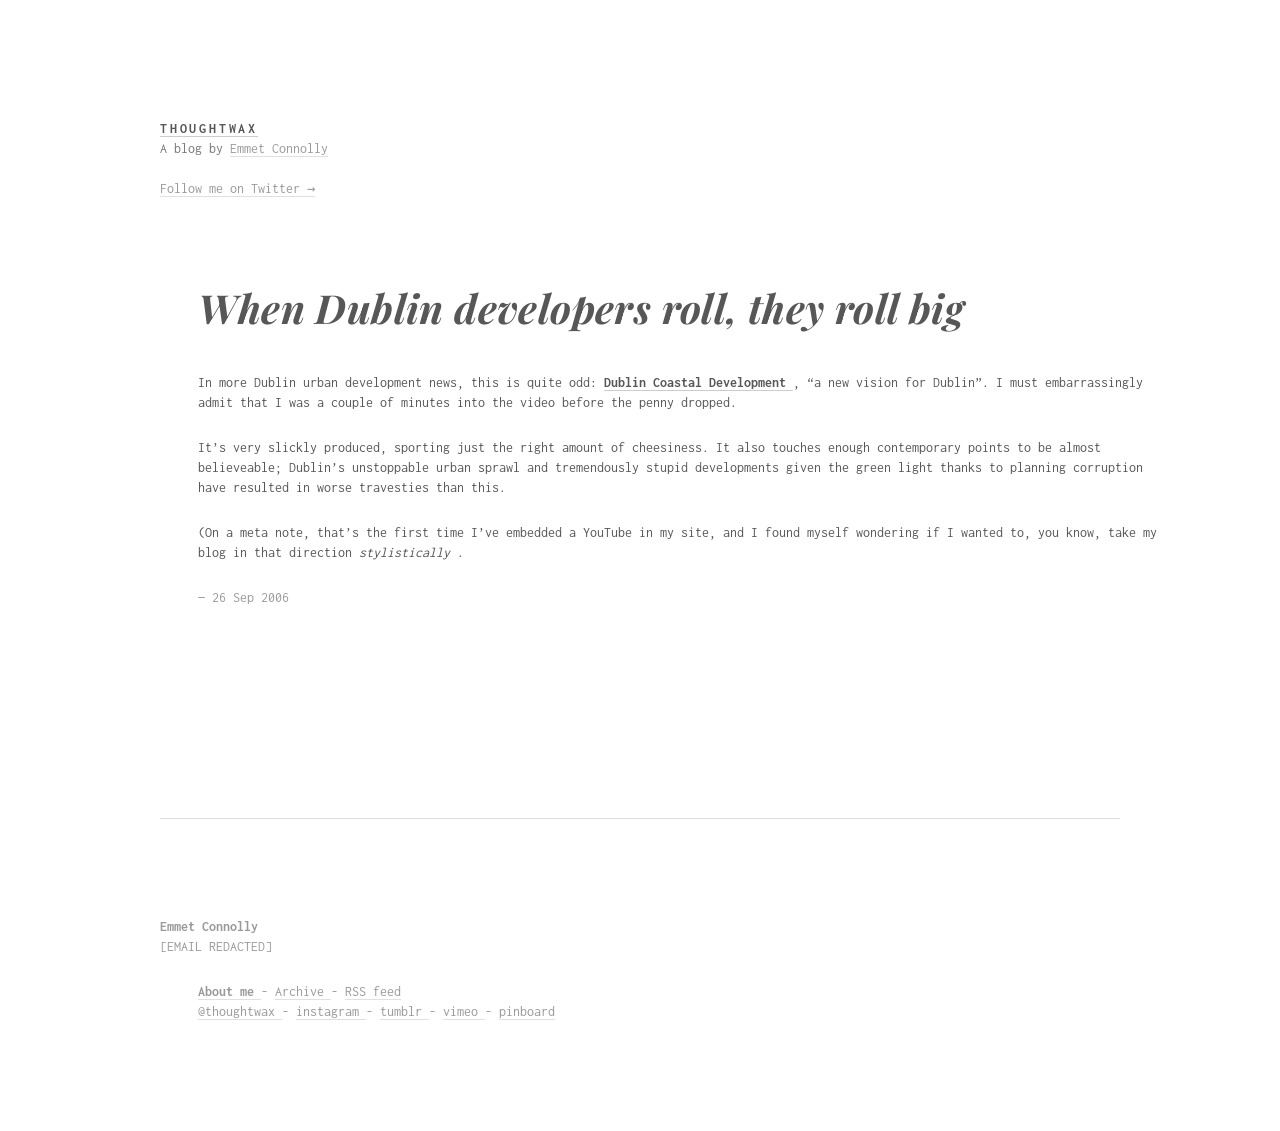How can I start building this website with HTML from the ground up? To build a website similar to the one shown in the image from scratch using HTML, start by creating a simple HTML structure. Decide on the sections you need, such as a header, main content area, and footer. Use HTML tags like <header>, <main>, and <footer> to define these areas. For the main content, use <article> tags to create individual blog posts or sections. Each post can have <h1> for the title and <p> for paragraphs. Style your website using CSS to match the minimalistic and clean style shown in the image. 